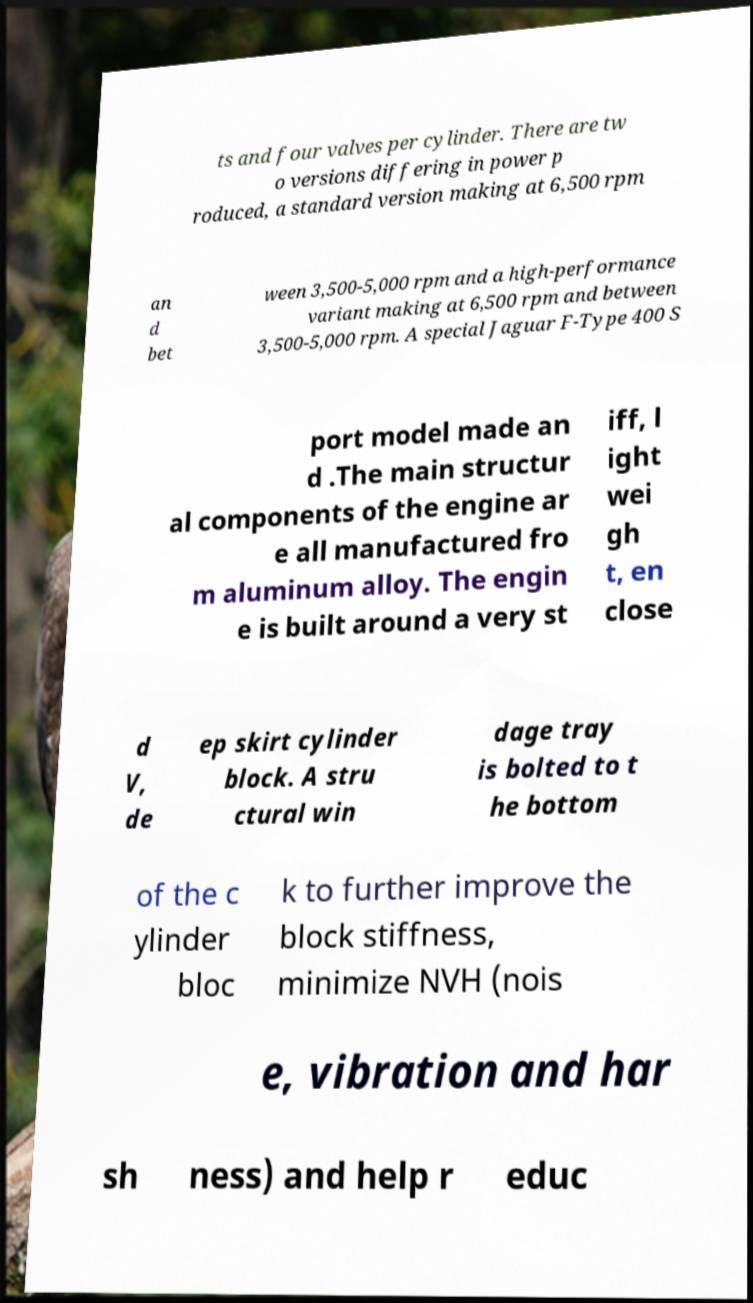For documentation purposes, I need the text within this image transcribed. Could you provide that? ts and four valves per cylinder. There are tw o versions differing in power p roduced, a standard version making at 6,500 rpm an d bet ween 3,500-5,000 rpm and a high-performance variant making at 6,500 rpm and between 3,500-5,000 rpm. A special Jaguar F-Type 400 S port model made an d .The main structur al components of the engine ar e all manufactured fro m aluminum alloy. The engin e is built around a very st iff, l ight wei gh t, en close d V, de ep skirt cylinder block. A stru ctural win dage tray is bolted to t he bottom of the c ylinder bloc k to further improve the block stiffness, minimize NVH (nois e, vibration and har sh ness) and help r educ 